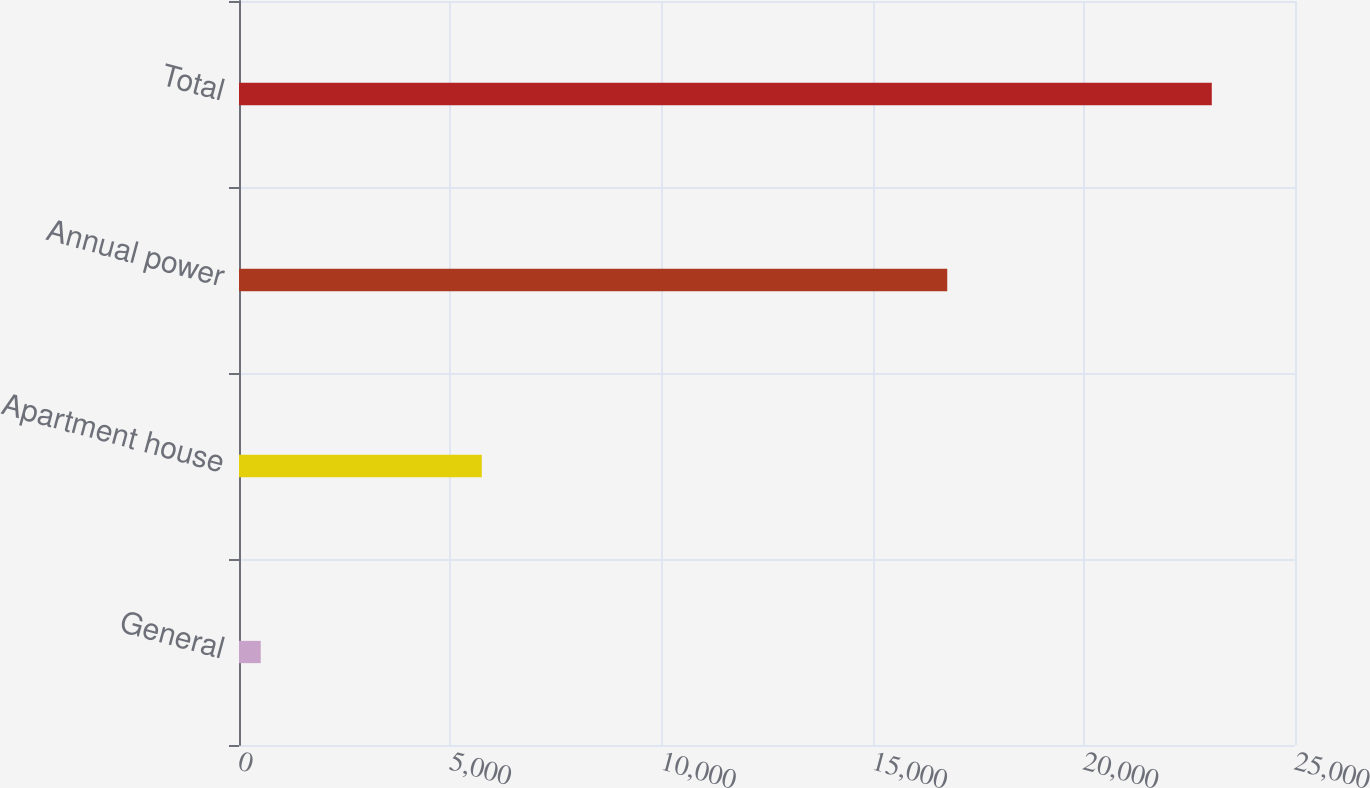Convert chart to OTSL. <chart><loc_0><loc_0><loc_500><loc_500><bar_chart><fcel>General<fcel>Apartment house<fcel>Annual power<fcel>Total<nl><fcel>515<fcel>5748<fcel>16767<fcel>23030<nl></chart> 